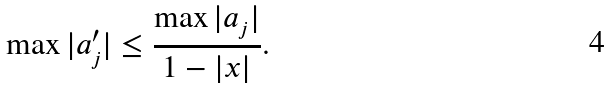<formula> <loc_0><loc_0><loc_500><loc_500>\max | a _ { j } ^ { \prime } | \leq \frac { \max | a _ { j } | } { 1 - | x | } .</formula> 